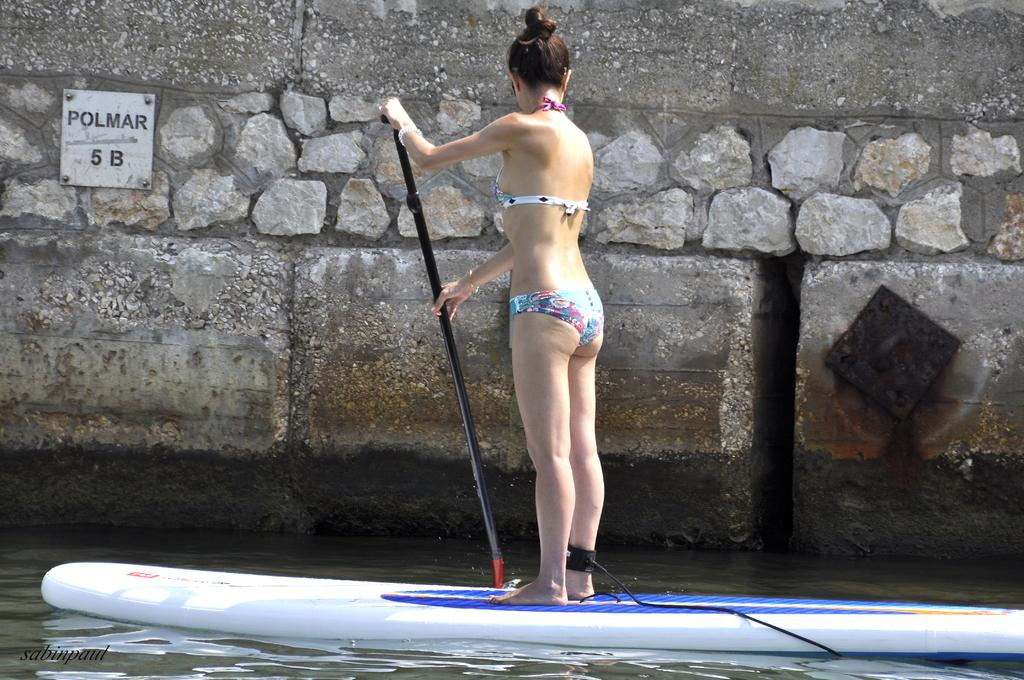What is the main subject in the foreground of the picture? There is a woman in the foreground of the picture. What is the woman doing in the image? The woman is standing on a surfboard and holding a paddle. What can be seen in the background of the image? There is water and a wall in the background of the image. What is on the wall in the background? There is a name board on the wall. What type of shade is being used by the woman in the image? There is no shade visible in the image; the woman is standing on a surfboard in the water. What color are the stockings worn by the woman in the image? The woman is not wearing stockings in the image; she is wearing a swimsuit. 